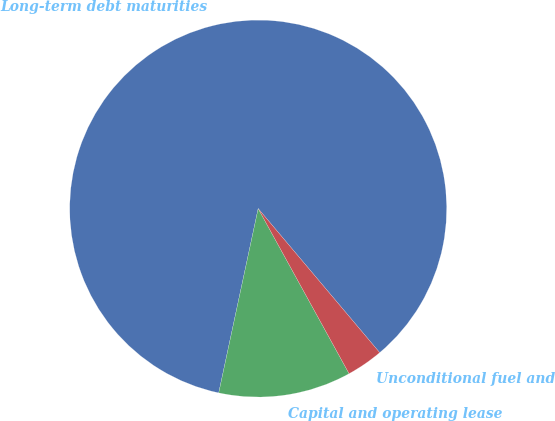<chart> <loc_0><loc_0><loc_500><loc_500><pie_chart><fcel>Long-term debt maturities<fcel>Capital and operating lease<fcel>Unconditional fuel and<nl><fcel>85.49%<fcel>11.37%<fcel>3.14%<nl></chart> 